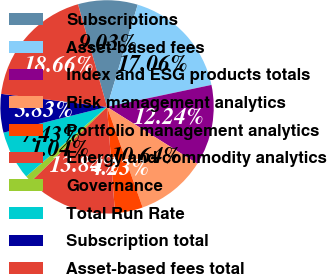Convert chart. <chart><loc_0><loc_0><loc_500><loc_500><pie_chart><fcel>Subscriptions<fcel>Asset-based fees<fcel>Index and ESG products totals<fcel>Risk management analytics<fcel>Portfolio management analytics<fcel>Energy and commodity analytics<fcel>Governance<fcel>Total Run Rate<fcel>Subscription total<fcel>Asset-based fees total<nl><fcel>9.03%<fcel>17.06%<fcel>12.24%<fcel>10.64%<fcel>4.23%<fcel>13.84%<fcel>1.04%<fcel>7.43%<fcel>5.83%<fcel>18.66%<nl></chart> 